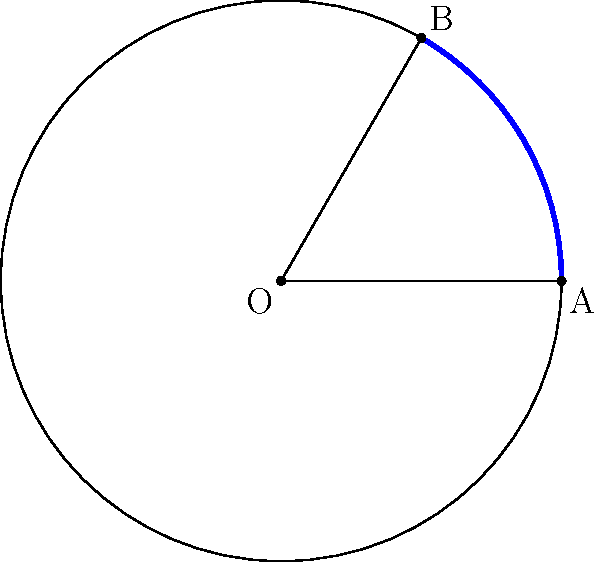In a circular reactor vessel, a novel detoxification process occurs along an arc AB. Given that the radius (r) of the vessel is 5 meters and the inscribed angle (θ) at the center is 60°, calculate the length of the arc AB where the detoxification process takes place. Express your answer in terms of π. To solve this problem, we'll follow these steps:

1) First, recall the formula for arc length (s) in terms of radius (r) and central angle (θ in radians):

   $$s = r\theta$$

2) We're given the inscribed angle, which is half the central angle. Let's call the central angle φ. We know:

   $$\phi = 2\theta = 2 * 60° = 120°$$

3) We need to convert the central angle from degrees to radians:

   $$\phi_{rad} = \frac{120°}{180°} * \pi = \frac{2\pi}{3}$$

4) Now we can substitute into our arc length formula:

   $$s = r\phi_{rad} = 5 * \frac{2\pi}{3}$$

5) Simplify:

   $$s = \frac{10\pi}{3}$$

This gives us the length of the arc where the detoxification process occurs.
Answer: $\frac{10\pi}{3}$ meters 